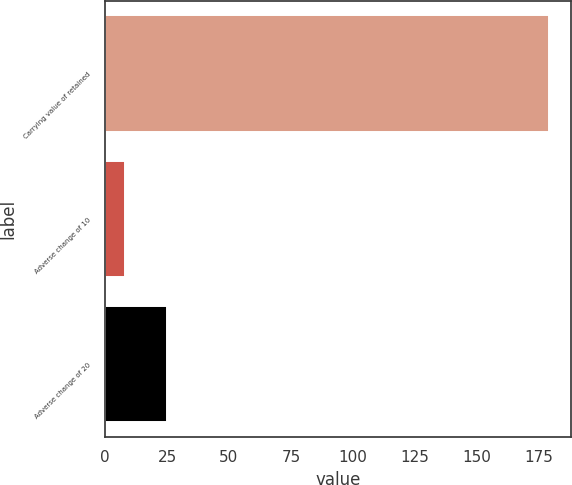<chart> <loc_0><loc_0><loc_500><loc_500><bar_chart><fcel>Carrying value of retained<fcel>Adverse change of 10<fcel>Adverse change of 20<nl><fcel>179<fcel>8<fcel>25.1<nl></chart> 